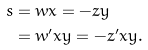<formula> <loc_0><loc_0><loc_500><loc_500>s & = w x = - z y \\ & = w ^ { \prime } x y = - z ^ { \prime } x y .</formula> 